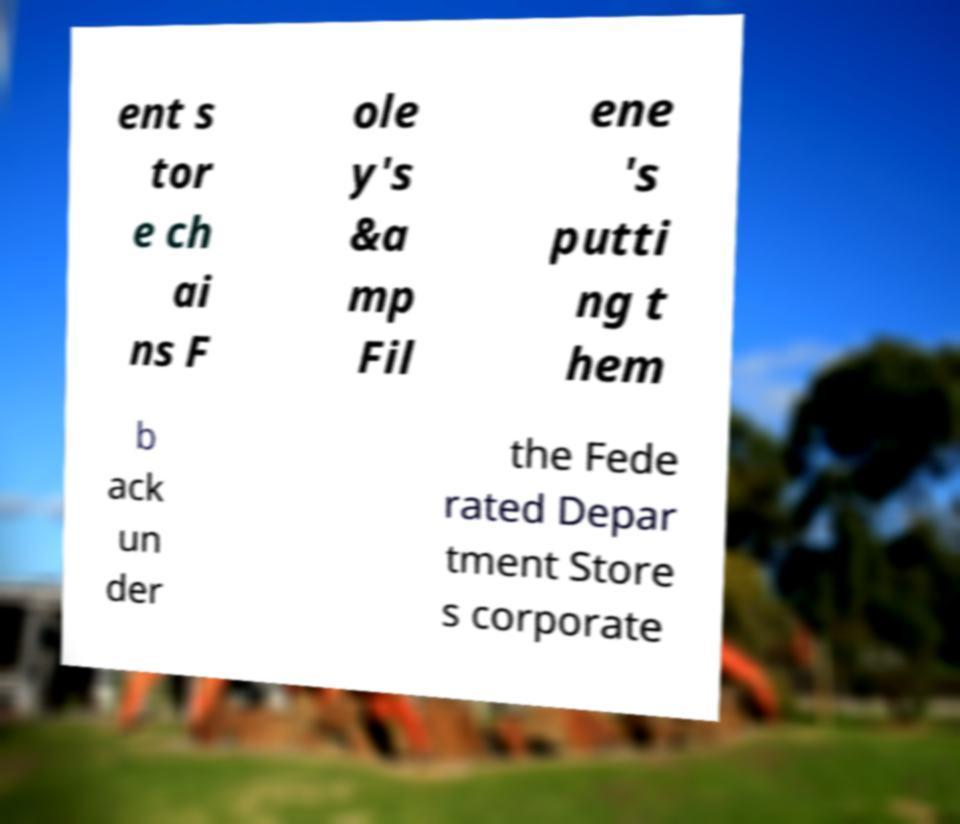I need the written content from this picture converted into text. Can you do that? ent s tor e ch ai ns F ole y's &a mp Fil ene 's putti ng t hem b ack un der the Fede rated Depar tment Store s corporate 